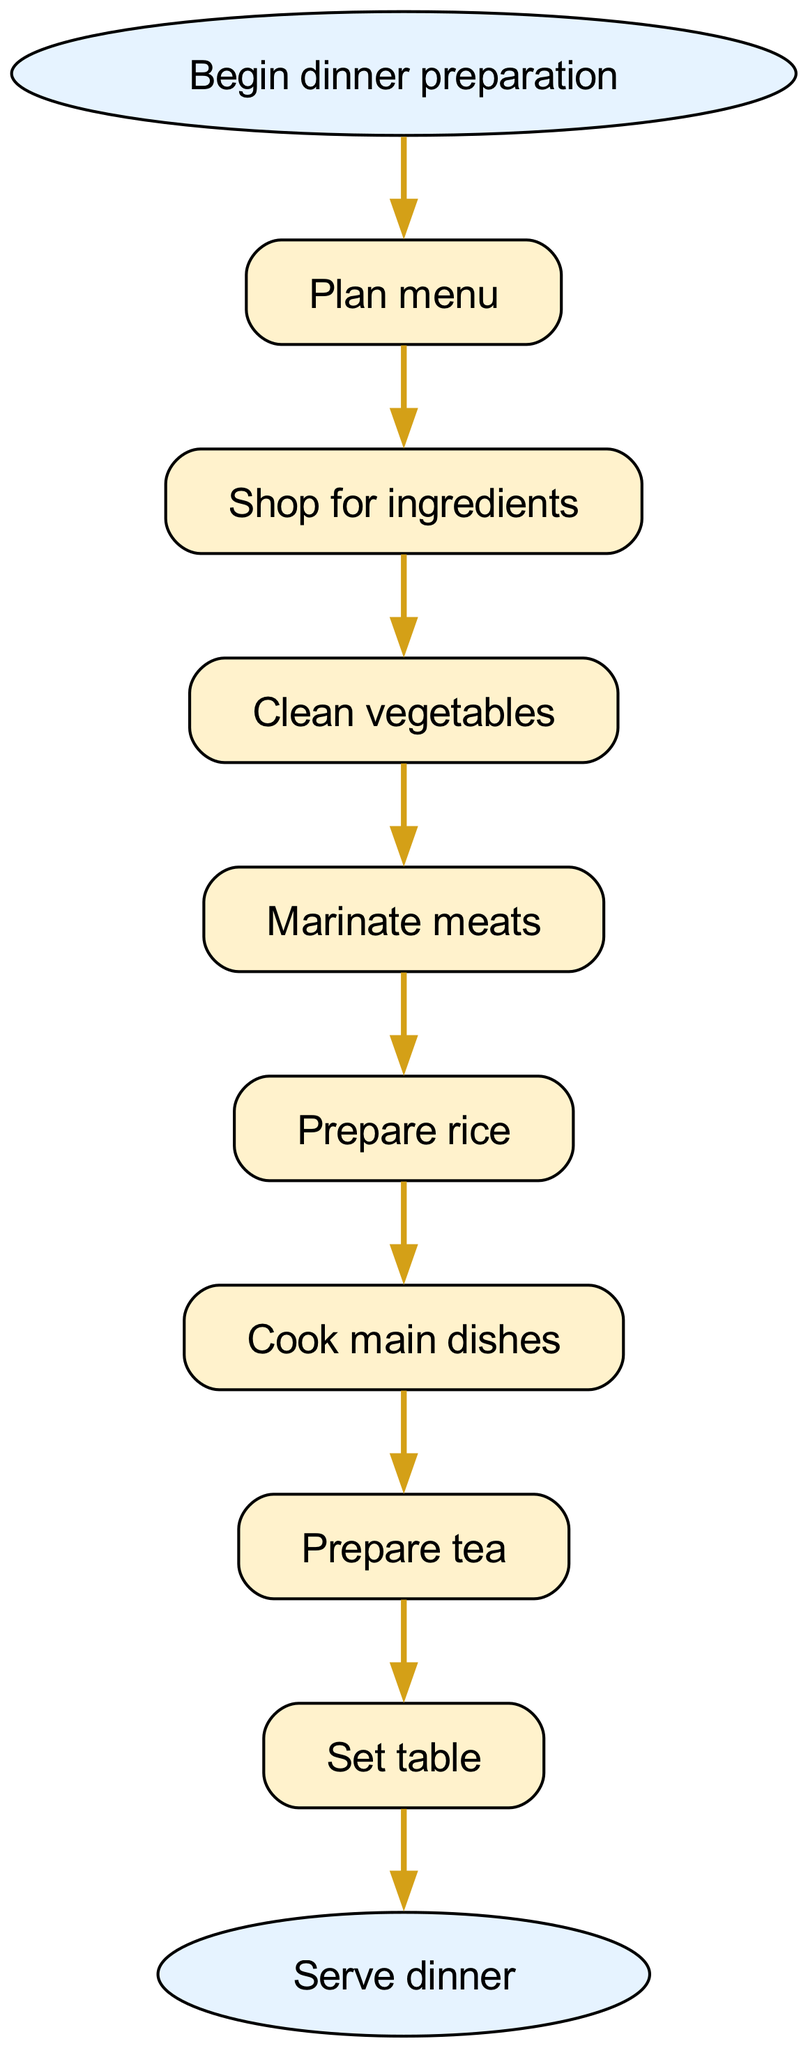What is the first step in the preparation? The first step in the preparation is indicated at the start of the diagram, labeled "Begin dinner preparation." Following this, the first task specified in the sequence is "Plan menu."
Answer: Plan menu How many steps are involved in the dinner preparation? To determine the number of steps, we count the individual steps listed in the diagram. There are eight distinct steps mentioned in the preparation process before serving dinner.
Answer: 8 What follows "Marinate meats"? In the flow of the diagram, after "Marinate meats," the next step is specifically labeled as "Prepare rice." This indicates the order of tasks.
Answer: Prepare rice What is the last action in the preparation process? According to the diagram, the final action before concluding the process is "Serve dinner." This marks the end of the preparation flow.
Answer: Serve dinner Which step comes immediately after "Prepare tea"? The diagram shows that right after "Prepare tea," the next task is "Set table." This clear sequential flow indicates the order of activities.
Answer: Set table What is the connection between "Clean vegetables" and "Cook main dishes"? The connection is sequential; "Clean vegetables" leads directly to "Marinate meats" and continues to "Prepare rice," which then leads to "Cook main dishes." Thus, they are part of the preparation chain.
Answer: Sequential connection How many edges appear in the diagram? Each step in the diagram creates a connection (edge) to the next step. Counting the edges, there are seven connections (one less than the number of steps) linking all the steps together.
Answer: 7 Which two steps are directly linked? For instance, "Shop for ingredients" and "Clean vegetables" are directly linked as one follows immediately after the other in the process. This shows their orderly relationship in preparation.
Answer: Shop for ingredients, Clean vegetables 